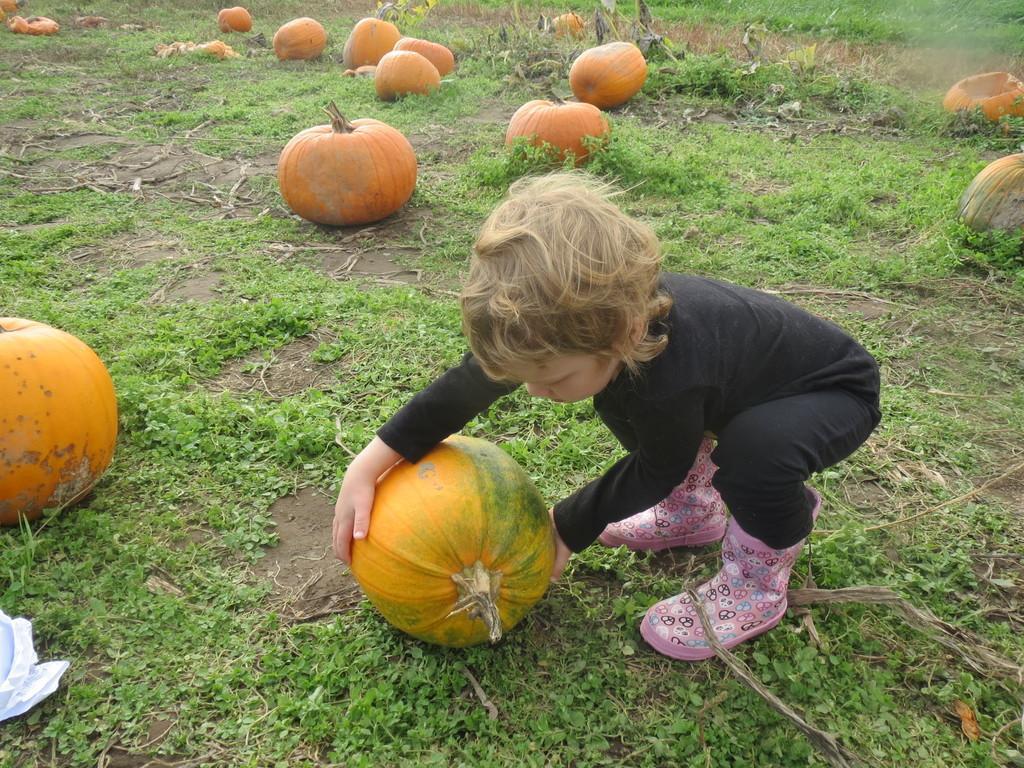Can you describe this image briefly? In this image I can see the person is holding the pumpkin. In the background I can see few pumpkins, grass and few sticks. 